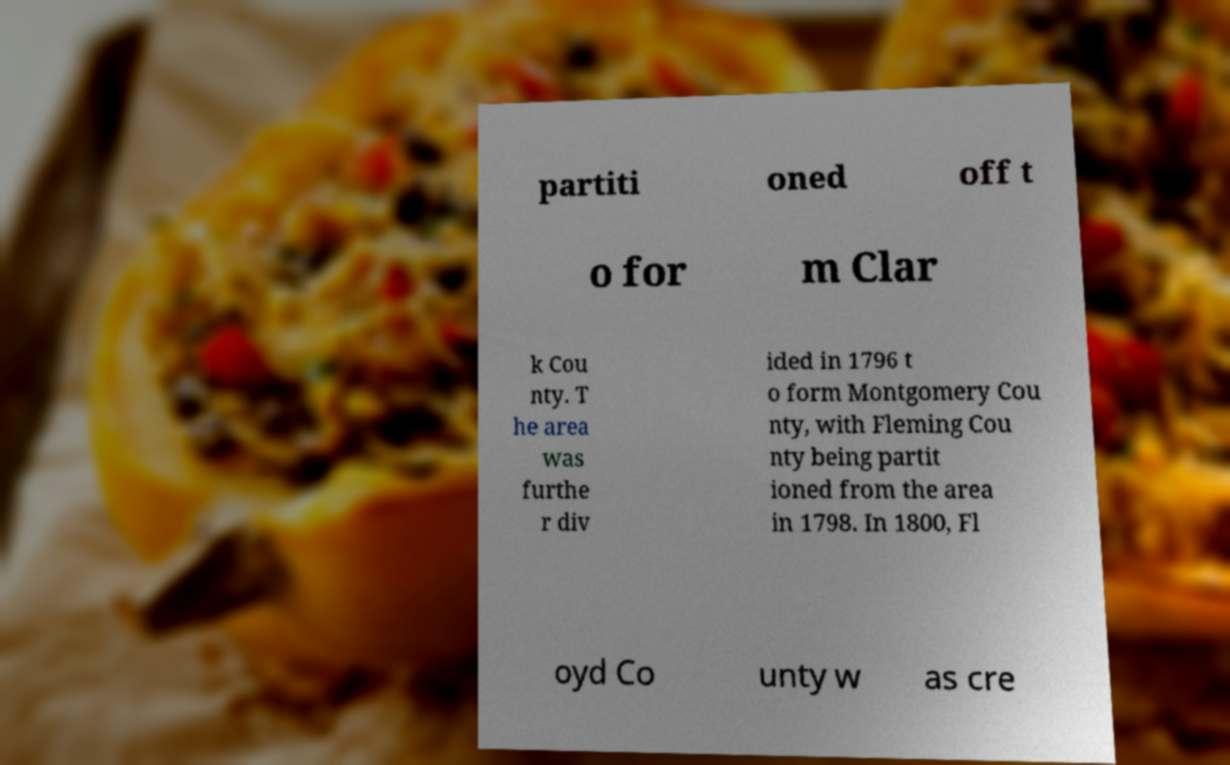Please read and relay the text visible in this image. What does it say? partiti oned off t o for m Clar k Cou nty. T he area was furthe r div ided in 1796 t o form Montgomery Cou nty, with Fleming Cou nty being partit ioned from the area in 1798. In 1800, Fl oyd Co unty w as cre 